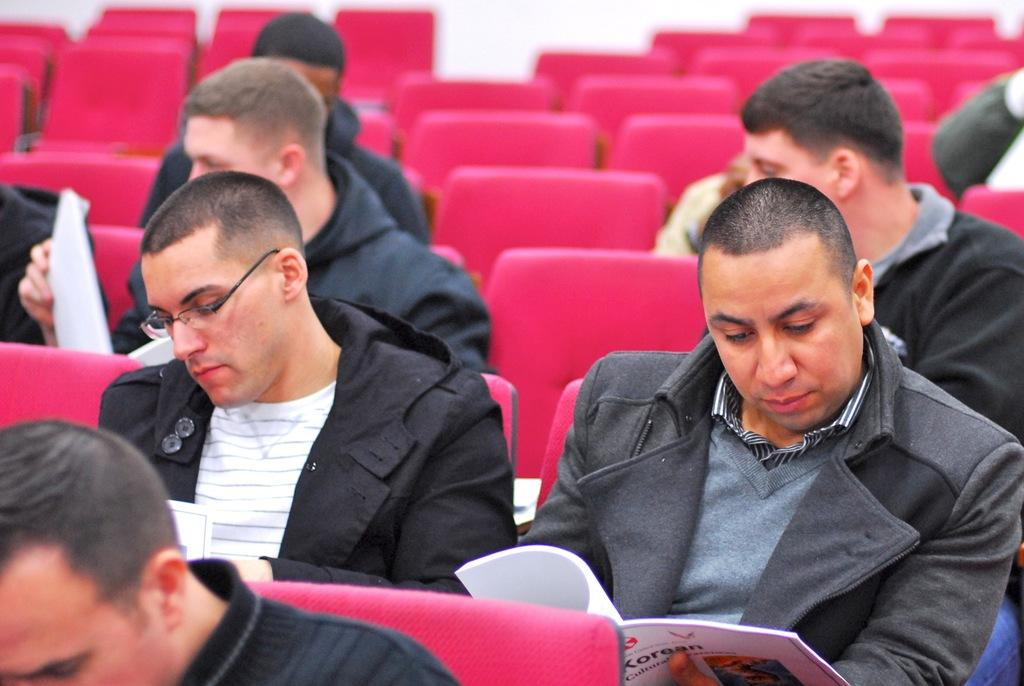What is the main subject of the image? The main subject of the image is a group of people. What are the people in the image doing? The people are sitting on chairs. What objects are some people holding in the image? Some people in the group are holding books. What type of mitten is being offered to the person in the image? There is no mitten present in the image, so it cannot be offered to anyone. 